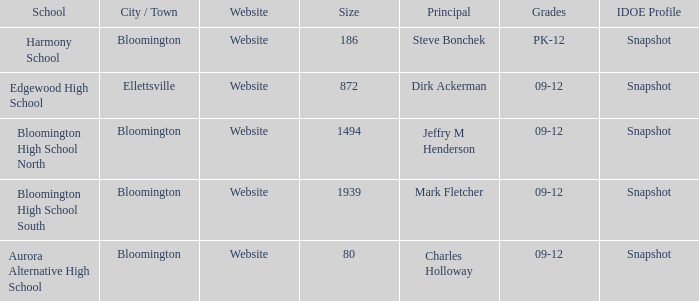Who's the principal of Edgewood High School?/ Dirk Ackerman. 